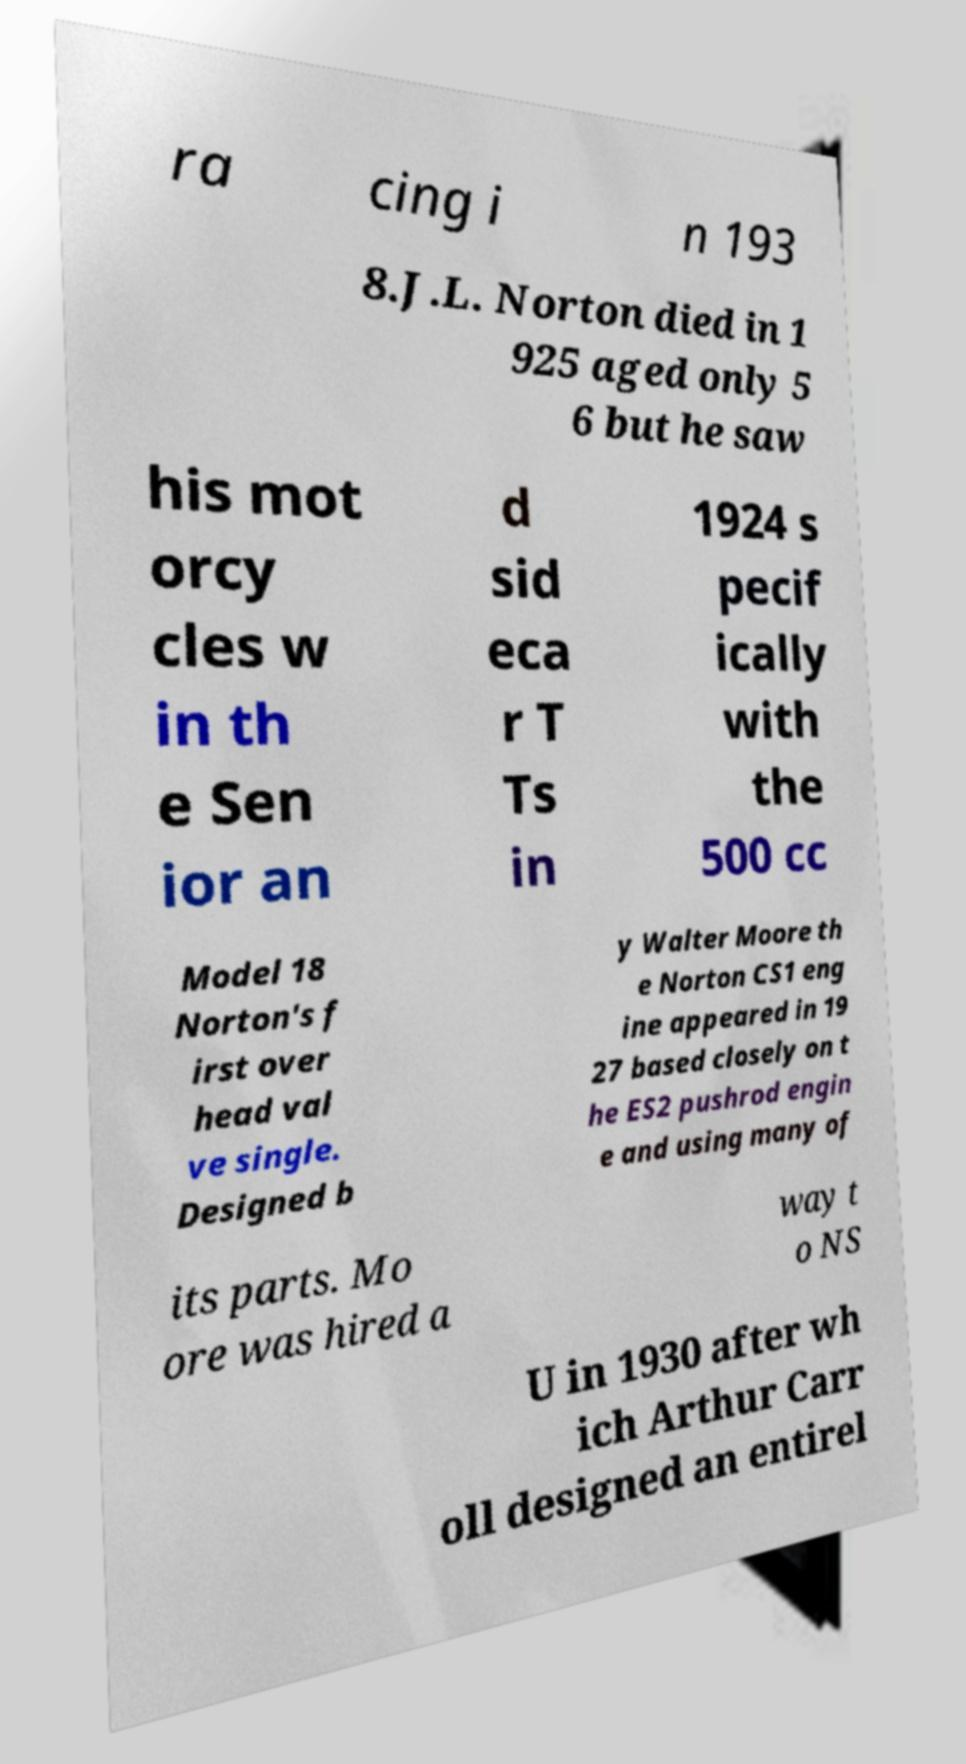For documentation purposes, I need the text within this image transcribed. Could you provide that? ra cing i n 193 8.J.L. Norton died in 1 925 aged only 5 6 but he saw his mot orcy cles w in th e Sen ior an d sid eca r T Ts in 1924 s pecif ically with the 500 cc Model 18 Norton's f irst over head val ve single. Designed b y Walter Moore th e Norton CS1 eng ine appeared in 19 27 based closely on t he ES2 pushrod engin e and using many of its parts. Mo ore was hired a way t o NS U in 1930 after wh ich Arthur Carr oll designed an entirel 